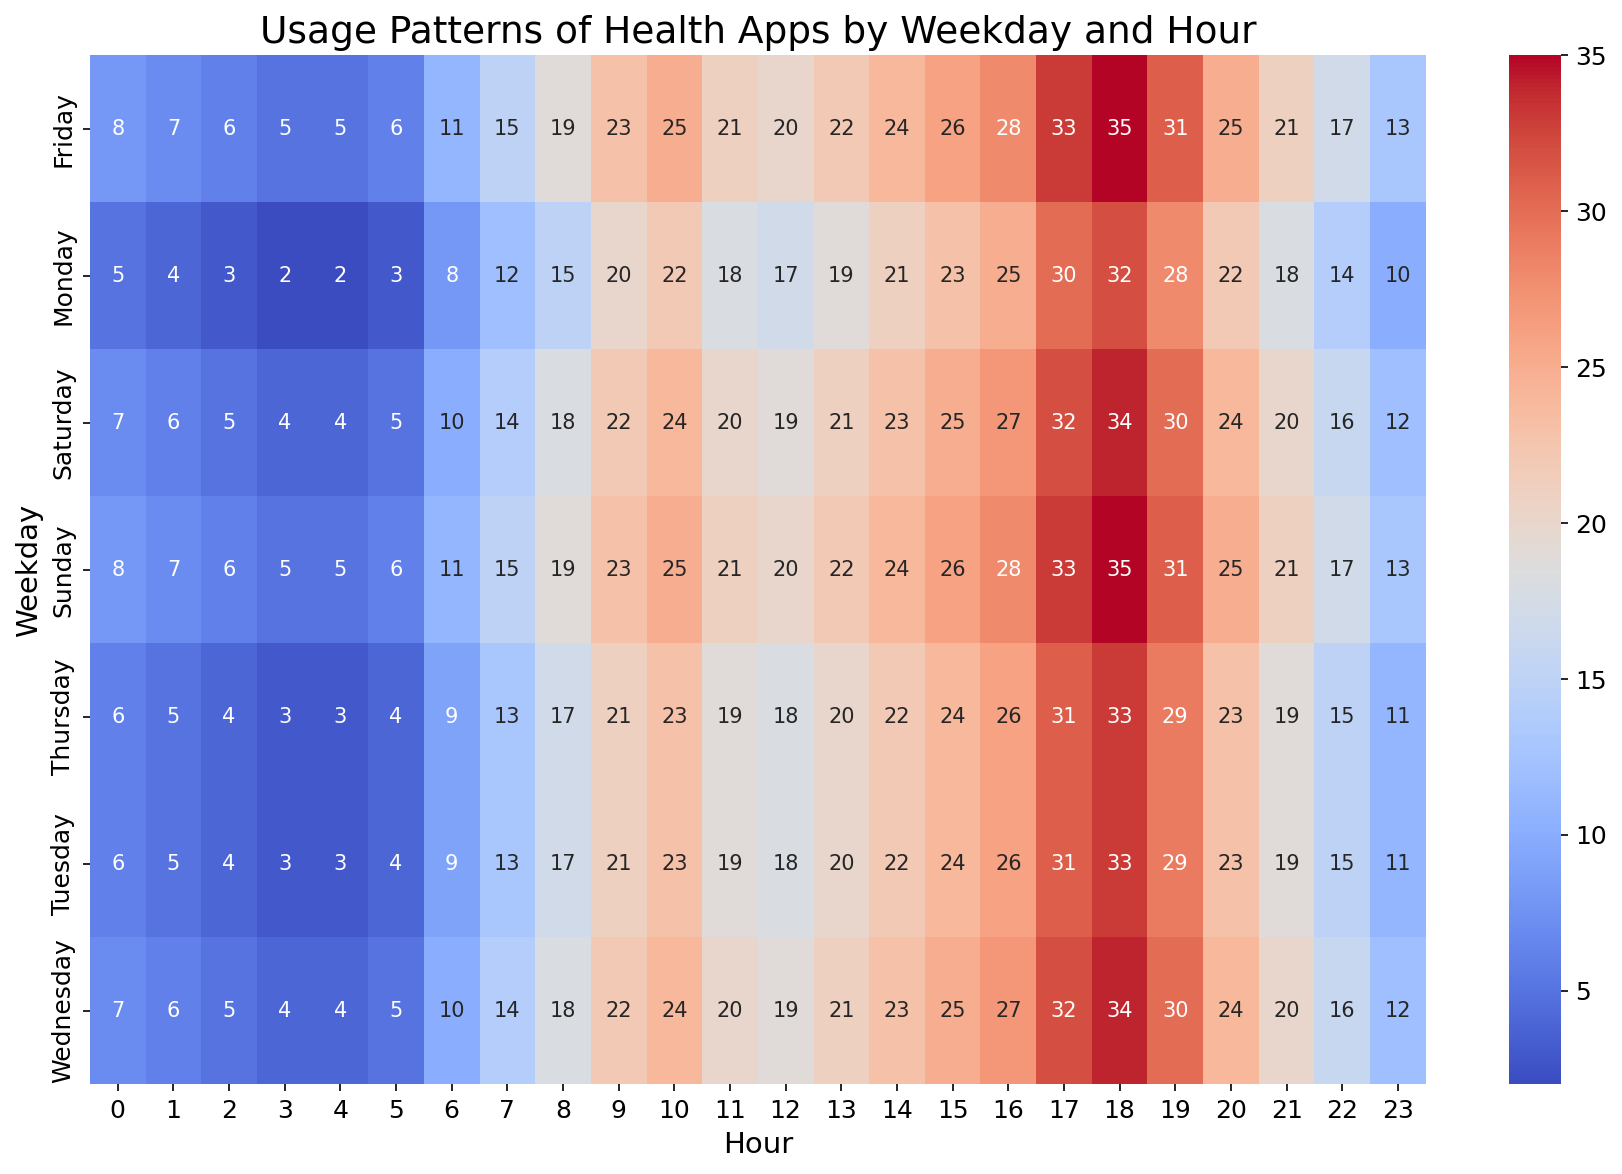What's the peak hour for app usage on Monday? Look at the heatmap for Monday and identify the hour with the highest value. From the heatmap, the highest usage value for Monday is 32 at 18:00.
Answer: 18:00 Which day has the highest app usage at 14:00? Examine the heatmap column for 14:00 and compare the values for each day. Wednesday has the highest value of 23 at 14:00.
Answer: Wednesday What's the average app usage on Fridays between 6:00 to 10:00? Check the usage values for Friday from 6:00 to 10:00 (11, 15, 19, 23, 25), sum them (11 + 15 + 19 + 23 + 25 = 93), and divide by the number of hours (5) to get the average.
Answer: 18.6 Is there a difference in app usage patterns between weekdays and weekends at 17:00? Compare the values at 17:00 for weekdays (Monday to Friday) and weekends (Saturday and Sunday). Weekday values are 30, 31, 32, 31, 33, and weekend values are 32, 33. The values are generally higher on weekends, indicating a slight increase in app usage.
Answer: Yes, higher on weekends What hour shows the least variation in app usage across different days of the week? Assess each hour's values across all days for variation. For example, for 3:00, the values are 2, 3, 4, 3, 5, 4, 5, showing low variation. 3:00 hr has low variation.
Answer: 3:00 Which day has the highest overall app usage? Compare the sum of usage values for each day. Summing up shows Sunday and Wednesday typically have higher usage patterns. Evaluating their pattern, Sunday has slightly higher usage consistently throughout the day.
Answer: Sunday How does the app usage at 21:00 on Saturday compare to the same time on Tuesday? Look at the values at 21:00 for Saturday and Tuesday. Saturday shows 20, and Tuesday has 19. Therefore, Saturday is slightly higher.
Answer: Saturday Which hour on Thursday has the lowest app usage? Check the heatmap for Thursday and identify the lowest value, which is 3 at 3:00 and 4:00 hrs.
Answer: 3:00 or 4:00 What is the total app usage on Sundays from 18:00 to 23:00? Sum the values for Sunday from 18:00 to 23:00 (35, 31, 25, 21, 17, 13). The total is 35 + 31 + 25 + 21 + 17 + 13 = 142.
Answer: 142 